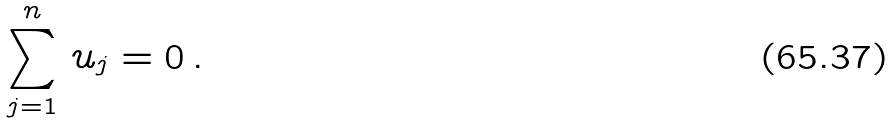Convert formula to latex. <formula><loc_0><loc_0><loc_500><loc_500>\sum ^ { n } _ { j = 1 } \, u _ { j } = 0 \, .</formula> 